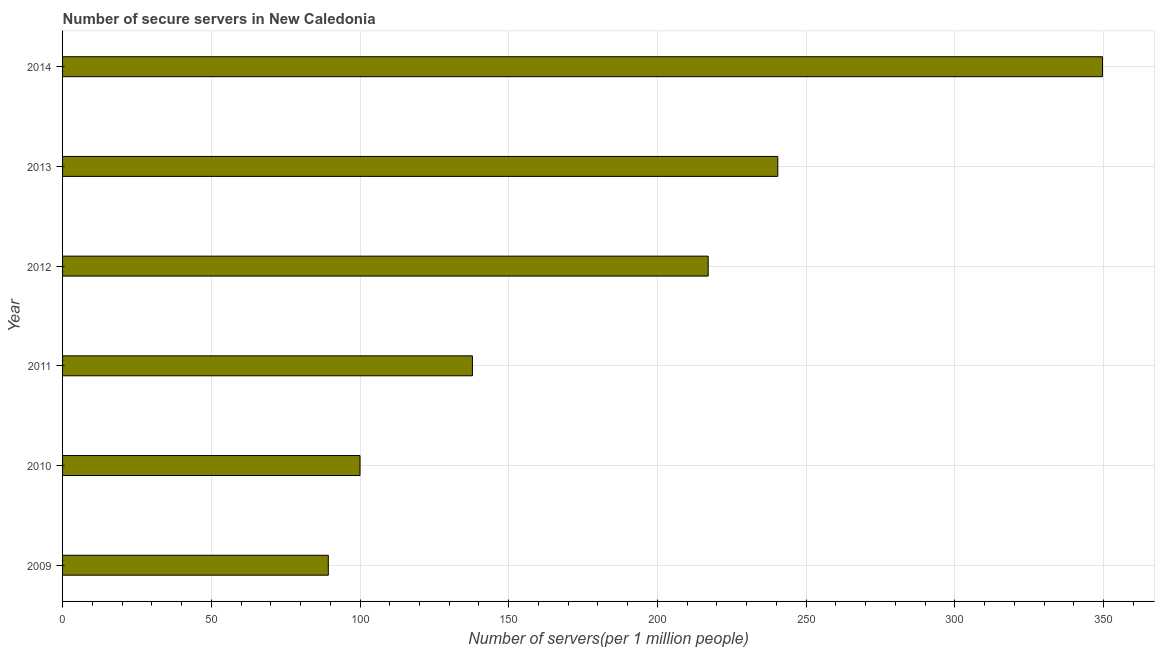Does the graph contain any zero values?
Your response must be concise. No. Does the graph contain grids?
Ensure brevity in your answer.  Yes. What is the title of the graph?
Give a very brief answer. Number of secure servers in New Caledonia. What is the label or title of the X-axis?
Provide a succinct answer. Number of servers(per 1 million people). What is the label or title of the Y-axis?
Your response must be concise. Year. What is the number of secure internet servers in 2012?
Keep it short and to the point. 217.05. Across all years, what is the maximum number of secure internet servers?
Ensure brevity in your answer.  349.62. Across all years, what is the minimum number of secure internet servers?
Your response must be concise. 89.34. In which year was the number of secure internet servers maximum?
Make the answer very short. 2014. What is the sum of the number of secure internet servers?
Give a very brief answer. 1134.27. What is the difference between the number of secure internet servers in 2013 and 2014?
Your response must be concise. -109.17. What is the average number of secure internet servers per year?
Offer a very short reply. 189.05. What is the median number of secure internet servers?
Your answer should be very brief. 177.42. In how many years, is the number of secure internet servers greater than 120 ?
Your response must be concise. 4. Do a majority of the years between 2014 and 2010 (inclusive) have number of secure internet servers greater than 200 ?
Your answer should be very brief. Yes. What is the ratio of the number of secure internet servers in 2011 to that in 2014?
Offer a terse response. 0.39. What is the difference between the highest and the second highest number of secure internet servers?
Offer a terse response. 109.17. What is the difference between the highest and the lowest number of secure internet servers?
Keep it short and to the point. 260.28. In how many years, is the number of secure internet servers greater than the average number of secure internet servers taken over all years?
Provide a succinct answer. 3. Are all the bars in the graph horizontal?
Make the answer very short. Yes. How many years are there in the graph?
Provide a short and direct response. 6. What is the difference between two consecutive major ticks on the X-axis?
Keep it short and to the point. 50. What is the Number of servers(per 1 million people) in 2009?
Ensure brevity in your answer.  89.34. What is the Number of servers(per 1 million people) in 2010?
Keep it short and to the point. 100. What is the Number of servers(per 1 million people) of 2011?
Make the answer very short. 137.8. What is the Number of servers(per 1 million people) of 2012?
Make the answer very short. 217.05. What is the Number of servers(per 1 million people) in 2013?
Give a very brief answer. 240.46. What is the Number of servers(per 1 million people) of 2014?
Your answer should be very brief. 349.62. What is the difference between the Number of servers(per 1 million people) in 2009 and 2010?
Your response must be concise. -10.66. What is the difference between the Number of servers(per 1 million people) in 2009 and 2011?
Offer a very short reply. -48.45. What is the difference between the Number of servers(per 1 million people) in 2009 and 2012?
Keep it short and to the point. -127.71. What is the difference between the Number of servers(per 1 million people) in 2009 and 2013?
Your response must be concise. -151.12. What is the difference between the Number of servers(per 1 million people) in 2009 and 2014?
Your answer should be compact. -260.28. What is the difference between the Number of servers(per 1 million people) in 2010 and 2011?
Your answer should be very brief. -37.8. What is the difference between the Number of servers(per 1 million people) in 2010 and 2012?
Your answer should be very brief. -117.05. What is the difference between the Number of servers(per 1 million people) in 2010 and 2013?
Give a very brief answer. -140.46. What is the difference between the Number of servers(per 1 million people) in 2010 and 2014?
Your answer should be very brief. -249.62. What is the difference between the Number of servers(per 1 million people) in 2011 and 2012?
Keep it short and to the point. -79.26. What is the difference between the Number of servers(per 1 million people) in 2011 and 2013?
Your answer should be compact. -102.66. What is the difference between the Number of servers(per 1 million people) in 2011 and 2014?
Make the answer very short. -211.83. What is the difference between the Number of servers(per 1 million people) in 2012 and 2013?
Keep it short and to the point. -23.4. What is the difference between the Number of servers(per 1 million people) in 2012 and 2014?
Your answer should be very brief. -132.57. What is the difference between the Number of servers(per 1 million people) in 2013 and 2014?
Offer a very short reply. -109.17. What is the ratio of the Number of servers(per 1 million people) in 2009 to that in 2010?
Your answer should be compact. 0.89. What is the ratio of the Number of servers(per 1 million people) in 2009 to that in 2011?
Give a very brief answer. 0.65. What is the ratio of the Number of servers(per 1 million people) in 2009 to that in 2012?
Give a very brief answer. 0.41. What is the ratio of the Number of servers(per 1 million people) in 2009 to that in 2013?
Give a very brief answer. 0.37. What is the ratio of the Number of servers(per 1 million people) in 2009 to that in 2014?
Offer a terse response. 0.26. What is the ratio of the Number of servers(per 1 million people) in 2010 to that in 2011?
Make the answer very short. 0.73. What is the ratio of the Number of servers(per 1 million people) in 2010 to that in 2012?
Your response must be concise. 0.46. What is the ratio of the Number of servers(per 1 million people) in 2010 to that in 2013?
Give a very brief answer. 0.42. What is the ratio of the Number of servers(per 1 million people) in 2010 to that in 2014?
Ensure brevity in your answer.  0.29. What is the ratio of the Number of servers(per 1 million people) in 2011 to that in 2012?
Your response must be concise. 0.64. What is the ratio of the Number of servers(per 1 million people) in 2011 to that in 2013?
Ensure brevity in your answer.  0.57. What is the ratio of the Number of servers(per 1 million people) in 2011 to that in 2014?
Provide a short and direct response. 0.39. What is the ratio of the Number of servers(per 1 million people) in 2012 to that in 2013?
Provide a succinct answer. 0.9. What is the ratio of the Number of servers(per 1 million people) in 2012 to that in 2014?
Ensure brevity in your answer.  0.62. What is the ratio of the Number of servers(per 1 million people) in 2013 to that in 2014?
Keep it short and to the point. 0.69. 